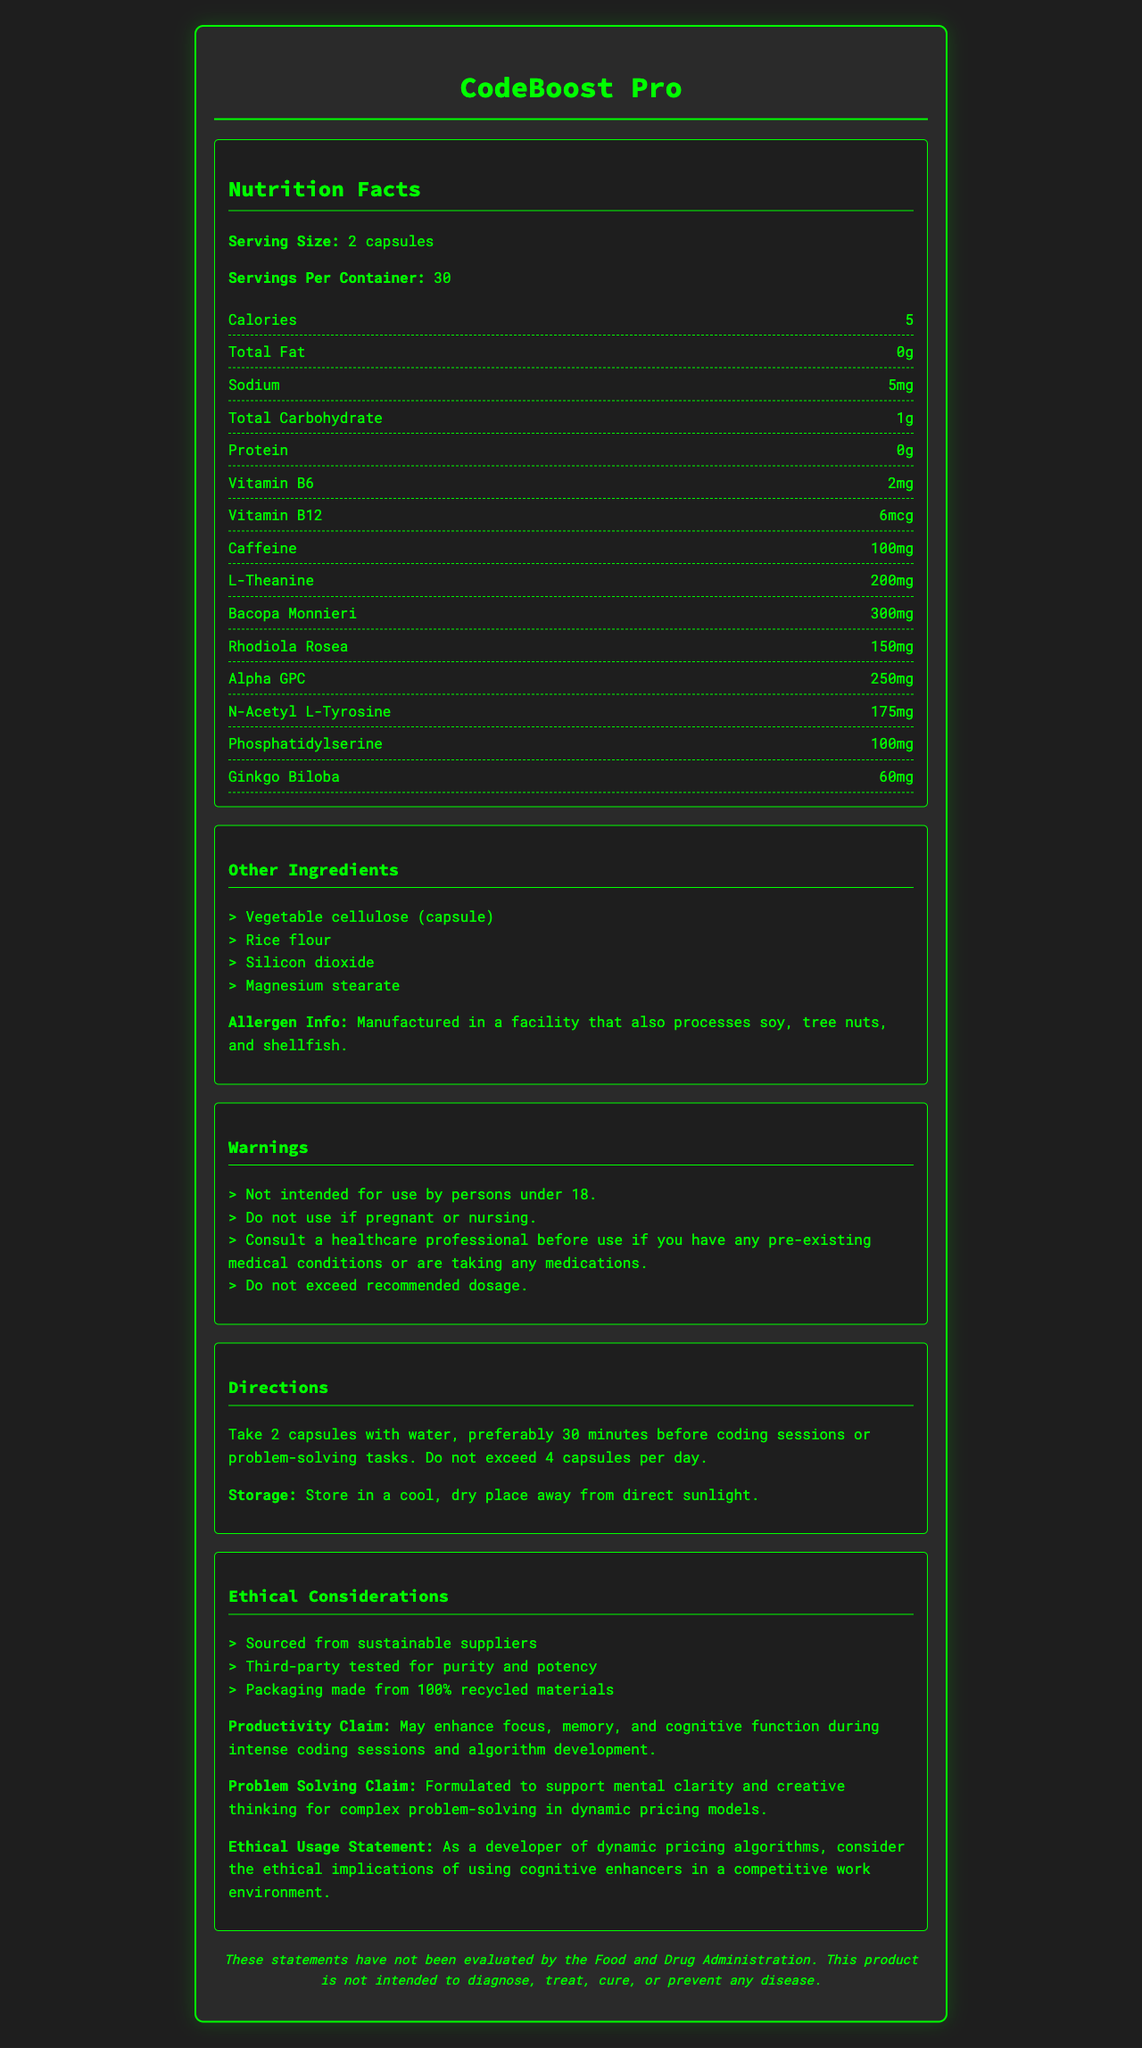What is the serving size of CodeBoost Pro? The serving size is mentioned as "2 capsules" under the Nutrition Facts.
Answer: 2 capsules How much caffeine is in each serving? The amount of caffeine per serving is listed as "100mg" under the Nutrition Facts.
Answer: 100mg What are the warnings listed on the label? The warnings are found in the section titled "Warnings" and are listed in bullet points.
Answer: Not intended for use by persons under 18, Do not use if pregnant or nursing, Consult a healthcare professional before use if you have any pre-existing medical conditions or are taking any medications, Do not exceed recommended dosage Which ingredient in CodeBoost Pro is present in the highest amount? In the Nutrition Facts list, Bacopa Monnieri is the ingredient with the highest quantity, listed at 300mg.
Answer: Bacopa Monnieri (300mg) How should CodeBoost Pro be stored? The storage instructions are provided in the "Directions" section.
Answer: Store in a cool, dry place away from direct sunlight. What are the sustainability practices mentioned for CodeBoost Pro? A. Sourced from sustainable suppliers B. Recyclable packaging C. Carbon-neutral shipping D. Third-party tested for purity and potency The sustainability practices are detailed in the "Ethical Considerations" section, which mentions sourcing from sustainable suppliers, third-party testing for purity and potency, and packaging made from 100% recycled materials.
Answer: A. Sourced from sustainable suppliers, B. Recyclable packaging, D. Third-party tested for purity and potency What additional benefits does CodeBoost Pro claim to offer for problem-solving tasks? A. Enhances focus B. Supports mental clarity C. Improves muscle strength D. Provides energy The productivity claim includes enhancement of focus and cognitive function, and the problem-solving claim includes supporting mental clarity and creative thinking.
Answer: A. Enhances focus, B. Supports mental clarity Can CodeBoost Pro be used by someone who is pregnant? According to the warnings, it should not be used if pregnant or nursing.
Answer: No Summarize the main idea of the CodeBoost Pro nutrition label. The document details the nutritional information, ingredients, warnings, directions, ethical considerations, and the claims made by the product.
Answer: CodeBoost Pro is a nootropic supplement designed to enhance coding productivity and problem-solving skills. It contains a variety of ingredients, including caffeine and various herbs, and is intended for adult use. The product is sustainably sourced, third-party tested, and comes with several warnings and directions for use. What is the recommended maximum number of CodeBoost Pro capsules to be taken per day? The directions state not to exceed 4 capsules per day.
Answer: 4 capsules What is the exact amount of Rhodiola Rosea in one serving of CodeBoost Pro? The Nutrition Facts list Rhodiola Rosea as containing 150mg per serving.
Answer: 150mg Who is the product intended for, according to the label? The warnings section states that the product is not intended for use by persons under 18.
Answer: Persons over 18 years old How is the packaging of CodeBoost Pro described in terms of sustainability? Under "Ethical Considerations", it is stated that the packaging is made from 100% recycled materials.
Answer: Made from 100% recycled materials What must be avoided according to the ethical usage statement for CodeBoost Pro? The ethical usage statement advises developers to consider the ethical implications in a competitive work environment.
Answer: The statement emphasizes considering the ethical implications of using cognitive enhancers in a competitive work environment. What is the percentage of daily value for Vitamin B12 in CodeBoost Pro? The document does not provide the percentage of daily value for Vitamin B12.
Answer: Cannot be determined 